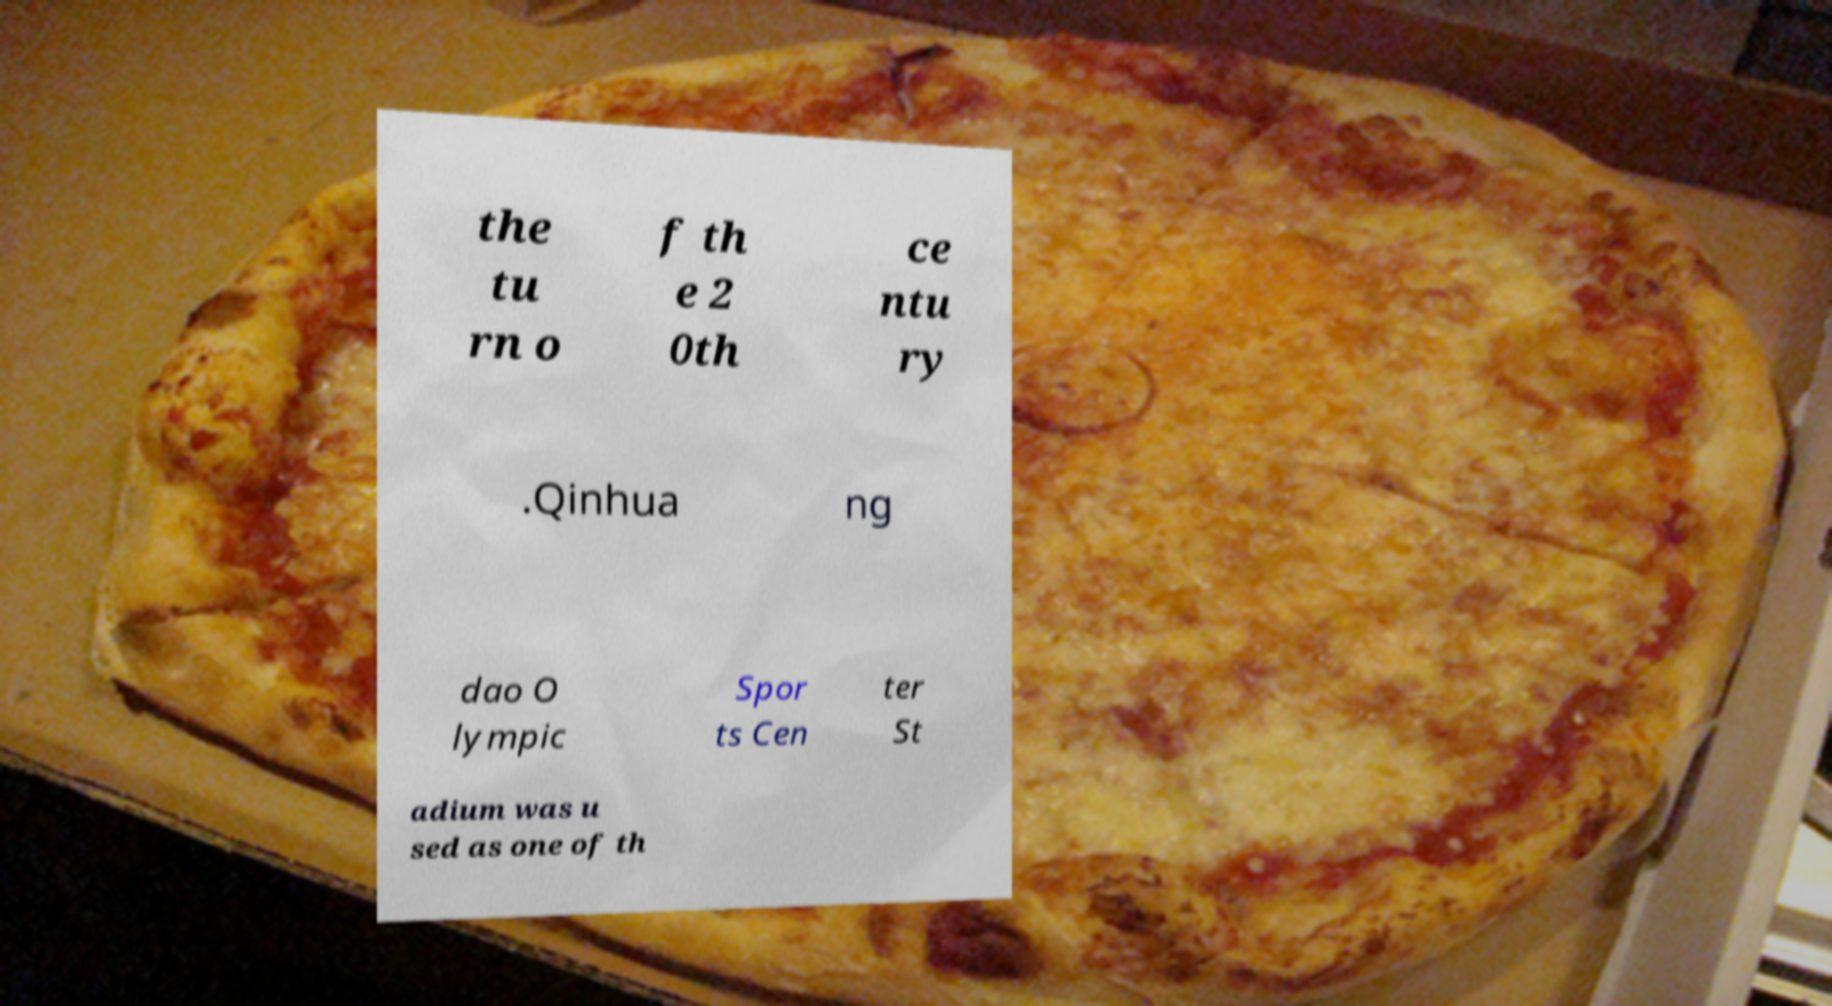Can you accurately transcribe the text from the provided image for me? the tu rn o f th e 2 0th ce ntu ry .Qinhua ng dao O lympic Spor ts Cen ter St adium was u sed as one of th 